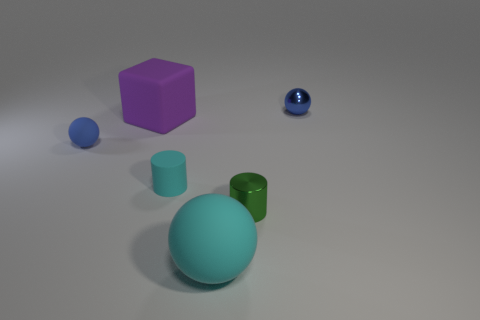The big matte object in front of the green shiny thing has what shape? The big matte object in front of the green shiny cylinder appears to be a sphere, characterized by its perfect roundness and lack of edges or vertices. 